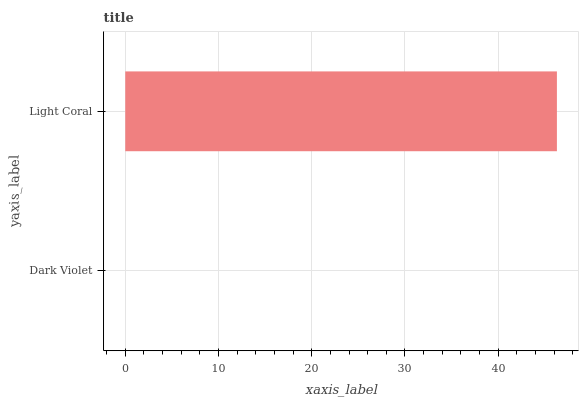Is Dark Violet the minimum?
Answer yes or no. Yes. Is Light Coral the maximum?
Answer yes or no. Yes. Is Light Coral the minimum?
Answer yes or no. No. Is Light Coral greater than Dark Violet?
Answer yes or no. Yes. Is Dark Violet less than Light Coral?
Answer yes or no. Yes. Is Dark Violet greater than Light Coral?
Answer yes or no. No. Is Light Coral less than Dark Violet?
Answer yes or no. No. Is Light Coral the high median?
Answer yes or no. Yes. Is Dark Violet the low median?
Answer yes or no. Yes. Is Dark Violet the high median?
Answer yes or no. No. Is Light Coral the low median?
Answer yes or no. No. 